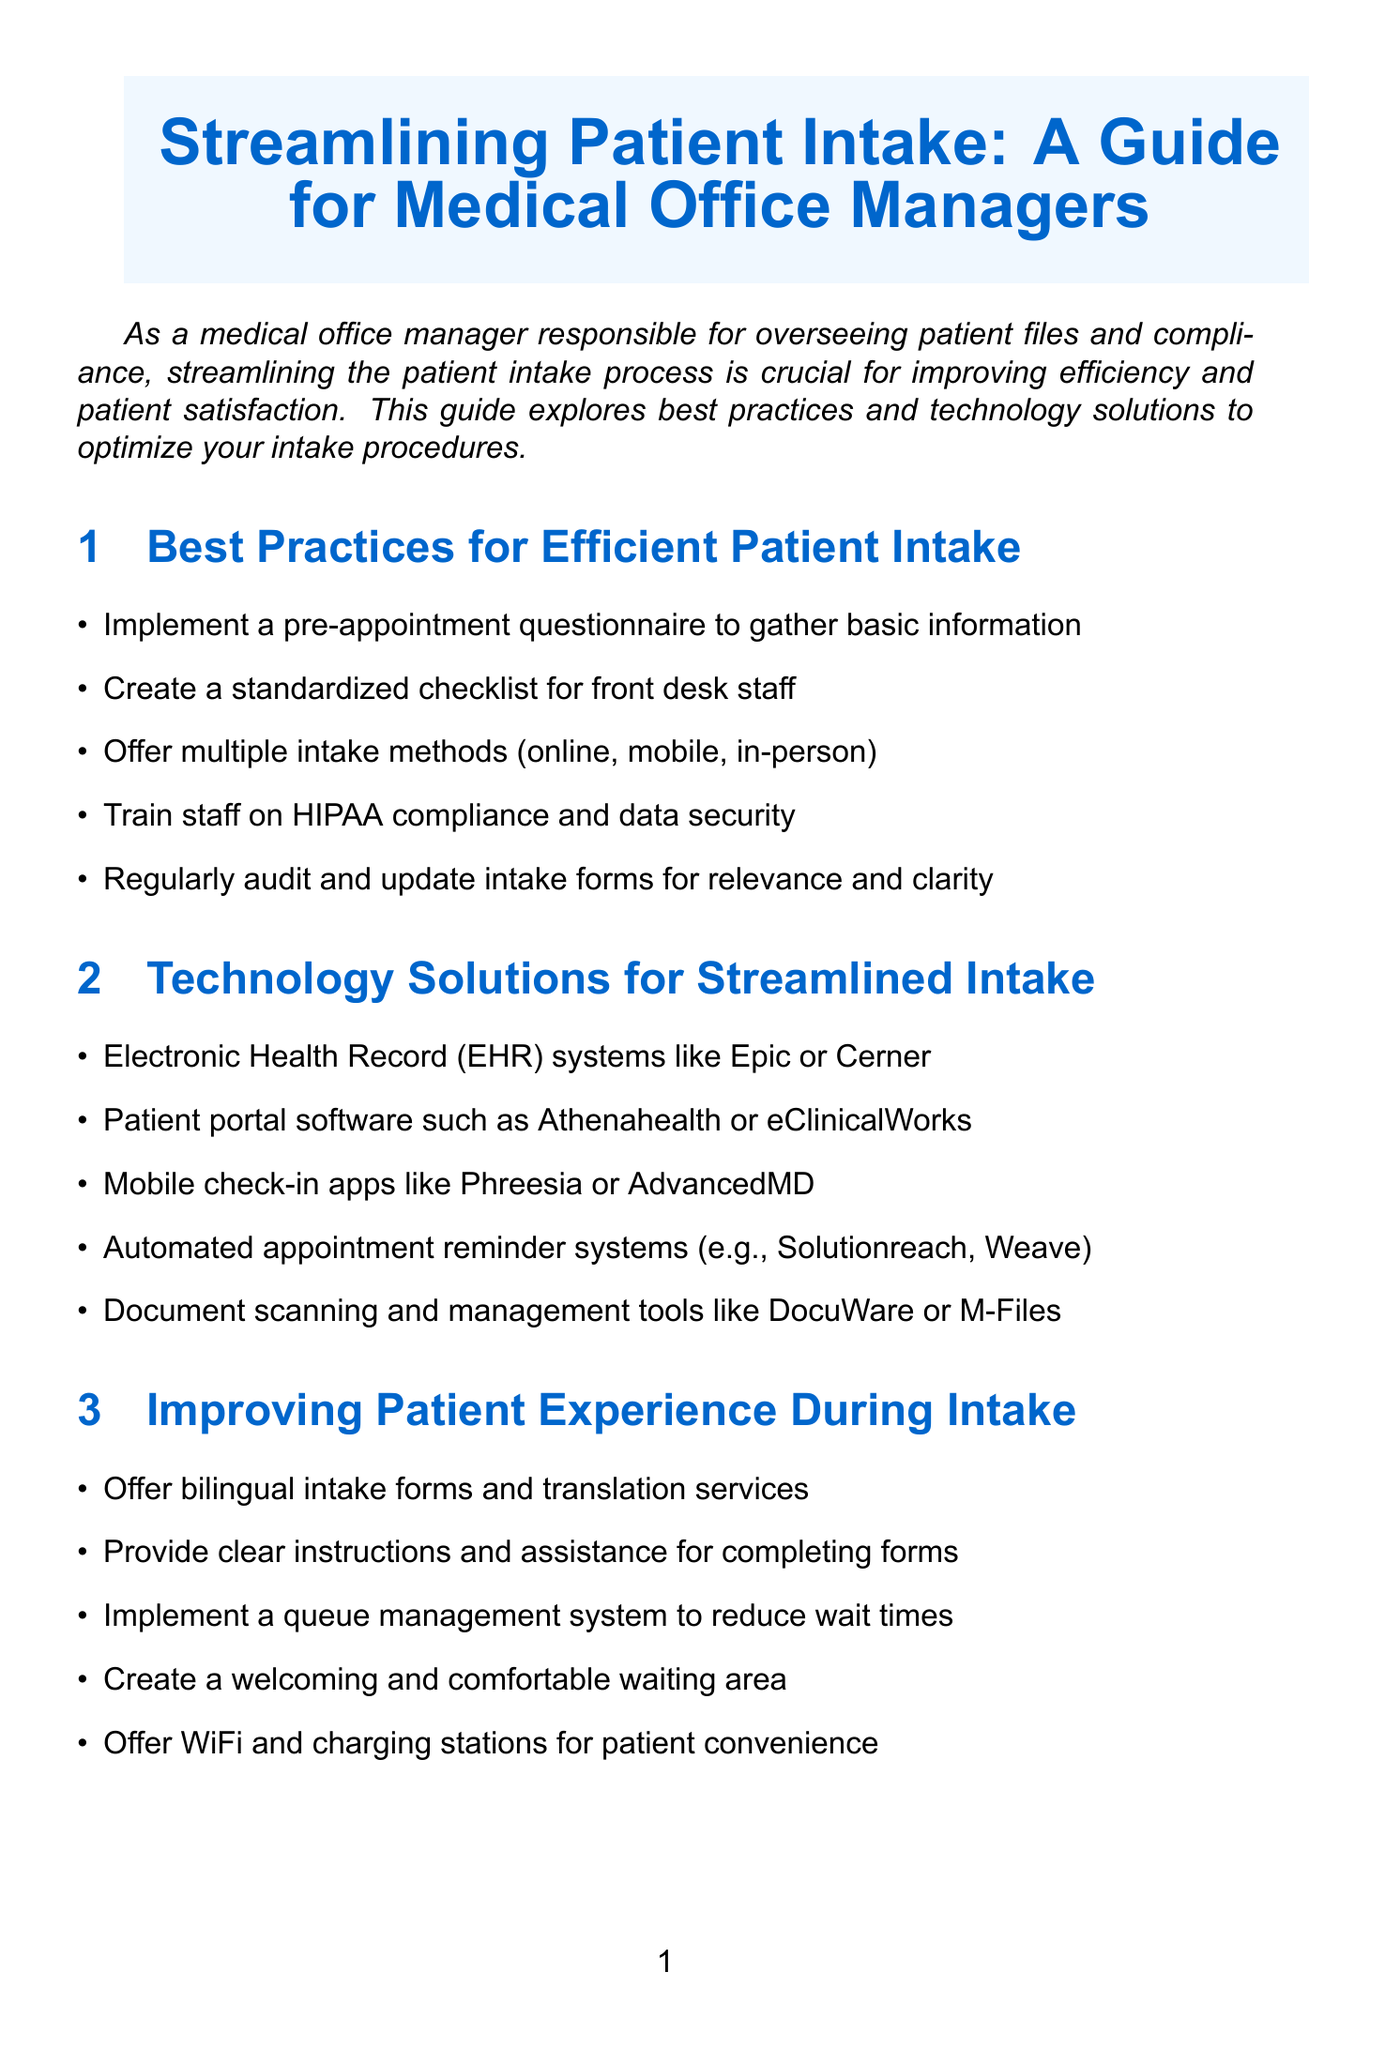What are the best practices for efficient patient intake? The document lists specific best practices in a section, including pre-appointment questionnaires and standardized checklists.
Answer: Pre-appointment questionnaire, standardized checklist, multiple intake methods, staff training, audit intake forms What technology solutions are suggested for streamlined intake? The section on technology solutions outlines various software and tools designed to improve the intake process.
Answer: EHR systems, patient portal software, mobile check-in apps, automated appointment reminders, document management tools How can patient experience during intake be improved? The document identifies strategies to enhance patient experience during the intake process, emphasizing comfort and support.
Answer: Bilingual forms, clear instructions, queue management, comfortable waiting area, WiFi and charging stations What should be implemented to ensure compliance and data security? The compliance section specifies necessary actions for maintaining privacy and security of patient data.
Answer: HIPAA-compliant software, role-based access controls, staff training, security audits, data breach response plan What key performance indicators should be tracked for measuring intake efficiency? The document lists specific metrics that can be evaluated to assess the efficiency of the intake process.
Answer: Average intake time How can medical office managers improve their current intake procedures? The call to action encourages managers to take specific steps to enhance their processes.
Answer: Assess current procedures, identify areas for improvement What type of patient forms can enhance communication with non-English speakers? The content in the improving patient experience section mentions solutions for language barriers.
Answer: Bilingual intake forms What is the purpose of regularly auditing intake forms? The document highlights the need for updates to maintain relevance and clarity in intake forms.
Answer: To ensure relevance and clarity Which software can assist with automated appointment reminders? The technology solutions section mentions specific tools for appointment reminders in the intake process.
Answer: Solutionreach, Weave 